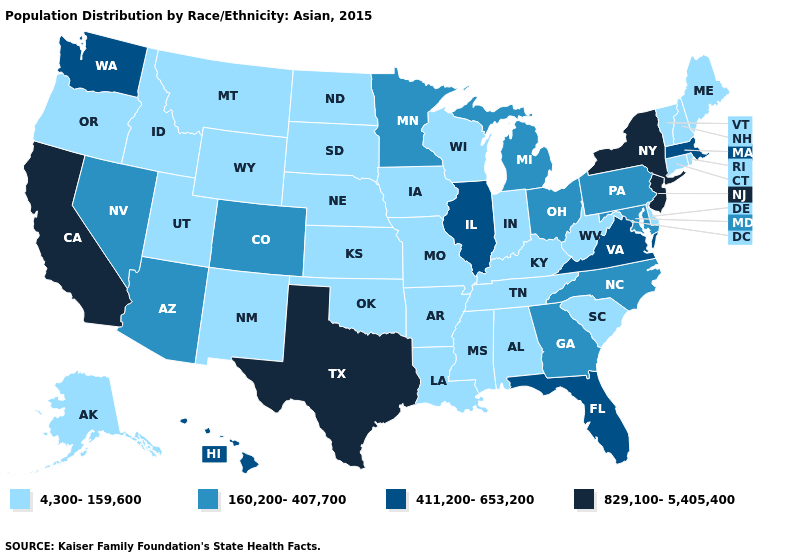Does West Virginia have the lowest value in the South?
Write a very short answer. Yes. What is the value of Massachusetts?
Concise answer only. 411,200-653,200. What is the value of Idaho?
Write a very short answer. 4,300-159,600. Among the states that border Vermont , which have the lowest value?
Concise answer only. New Hampshire. Name the states that have a value in the range 4,300-159,600?
Write a very short answer. Alabama, Alaska, Arkansas, Connecticut, Delaware, Idaho, Indiana, Iowa, Kansas, Kentucky, Louisiana, Maine, Mississippi, Missouri, Montana, Nebraska, New Hampshire, New Mexico, North Dakota, Oklahoma, Oregon, Rhode Island, South Carolina, South Dakota, Tennessee, Utah, Vermont, West Virginia, Wisconsin, Wyoming. Name the states that have a value in the range 4,300-159,600?
Be succinct. Alabama, Alaska, Arkansas, Connecticut, Delaware, Idaho, Indiana, Iowa, Kansas, Kentucky, Louisiana, Maine, Mississippi, Missouri, Montana, Nebraska, New Hampshire, New Mexico, North Dakota, Oklahoma, Oregon, Rhode Island, South Carolina, South Dakota, Tennessee, Utah, Vermont, West Virginia, Wisconsin, Wyoming. What is the highest value in the Northeast ?
Short answer required. 829,100-5,405,400. Among the states that border Louisiana , which have the lowest value?
Be succinct. Arkansas, Mississippi. What is the highest value in the West ?
Keep it brief. 829,100-5,405,400. Among the states that border Alabama , which have the highest value?
Keep it brief. Florida. Name the states that have a value in the range 4,300-159,600?
Keep it brief. Alabama, Alaska, Arkansas, Connecticut, Delaware, Idaho, Indiana, Iowa, Kansas, Kentucky, Louisiana, Maine, Mississippi, Missouri, Montana, Nebraska, New Hampshire, New Mexico, North Dakota, Oklahoma, Oregon, Rhode Island, South Carolina, South Dakota, Tennessee, Utah, Vermont, West Virginia, Wisconsin, Wyoming. What is the value of Maine?
Answer briefly. 4,300-159,600. What is the value of Vermont?
Give a very brief answer. 4,300-159,600. Among the states that border Alabama , does Tennessee have the highest value?
Concise answer only. No. Does the first symbol in the legend represent the smallest category?
Give a very brief answer. Yes. 